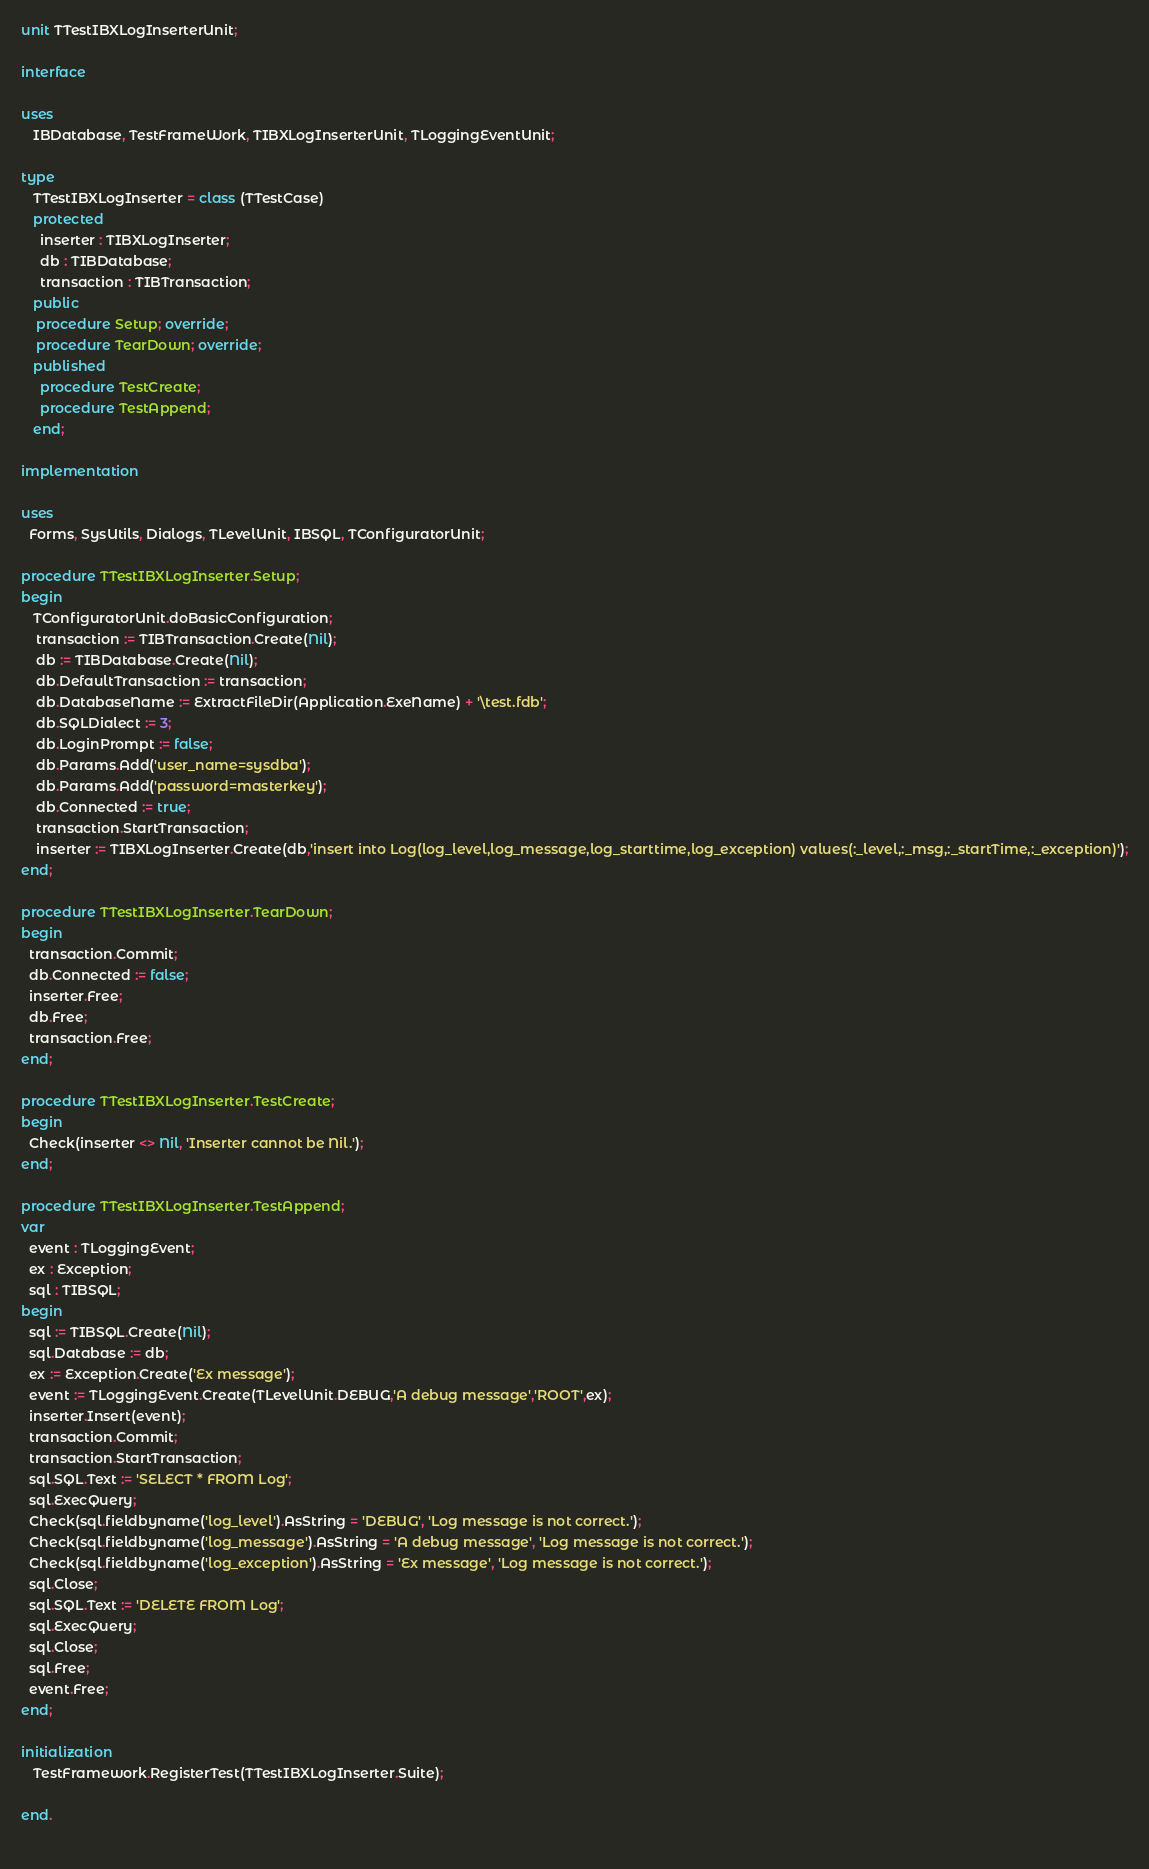Convert code to text. <code><loc_0><loc_0><loc_500><loc_500><_Pascal_>unit TTestIBXLogInserterUnit;

interface

uses
   IBDatabase, TestFrameWork, TIBXLogInserterUnit, TLoggingEventUnit;

type
   TTestIBXLogInserter = class (TTestCase)
   protected
     inserter : TIBXLogInserter;
     db : TIBDatabase;
     transaction : TIBTransaction;
   public
    procedure Setup; override;
    procedure TearDown; override;
   published
     procedure TestCreate;
     procedure TestAppend;
   end;

implementation

uses
  Forms, SysUtils, Dialogs, TLevelUnit, IBSQL, TConfiguratorUnit;

procedure TTestIBXLogInserter.Setup;
begin
   TConfiguratorUnit.doBasicConfiguration;
    transaction := TIBTransaction.Create(Nil);
    db := TIBDatabase.Create(Nil);
    db.DefaultTransaction := transaction;
    db.DatabaseName := ExtractFileDir(Application.ExeName) + '\test.fdb';
    db.SQLDialect := 3;
    db.LoginPrompt := false;
    db.Params.Add('user_name=sysdba');
    db.Params.Add('password=masterkey');
    db.Connected := true;
    transaction.StartTransaction;
    inserter := TIBXLogInserter.Create(db,'insert into Log(log_level,log_message,log_starttime,log_exception) values(:_level,:_msg,:_startTime,:_exception)');
end;

procedure TTestIBXLogInserter.TearDown;
begin
  transaction.Commit;
  db.Connected := false;
  inserter.Free;
  db.Free;
  transaction.Free;
end;

procedure TTestIBXLogInserter.TestCreate;
begin
  Check(inserter <> Nil, 'Inserter cannot be Nil.');
end;

procedure TTestIBXLogInserter.TestAppend;
var
  event : TLoggingEvent;
  ex : Exception;
  sql : TIBSQL;
begin
  sql := TIBSQL.Create(Nil);
  sql.Database := db;
  ex := Exception.Create('Ex message');
  event := TLoggingEvent.Create(TLevelUnit.DEBUG,'A debug message','ROOT',ex);
  inserter.Insert(event);
  transaction.Commit;
  transaction.StartTransaction;
  sql.SQL.Text := 'SELECT * FROM Log';
  sql.ExecQuery;
  Check(sql.fieldbyname('log_level').AsString = 'DEBUG', 'Log message is not correct.');
  Check(sql.fieldbyname('log_message').AsString = 'A debug message', 'Log message is not correct.');
  Check(sql.fieldbyname('log_exception').AsString = 'Ex message', 'Log message is not correct.');
  sql.Close;
  sql.SQL.Text := 'DELETE FROM Log';
  sql.ExecQuery;
  sql.Close;
  sql.Free;
  event.Free;
end;

initialization
   TestFramework.RegisterTest(TTestIBXLogInserter.Suite);

end.
 </code> 